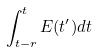<formula> <loc_0><loc_0><loc_500><loc_500>\int _ { t - r } ^ { t } E ( t ^ { \prime } ) d t</formula> 